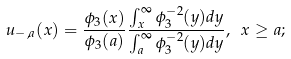Convert formula to latex. <formula><loc_0><loc_0><loc_500><loc_500>u _ { - , a } ( x ) = \frac { \phi _ { 3 } ( x ) } { \phi _ { 3 } ( a ) } \frac { \int _ { x } ^ { \infty } \phi _ { 3 } ^ { - 2 } ( y ) d y } { \int _ { a } ^ { \infty } \phi _ { 3 } ^ { - 2 } ( y ) d y } , \ x \geq a ;</formula> 